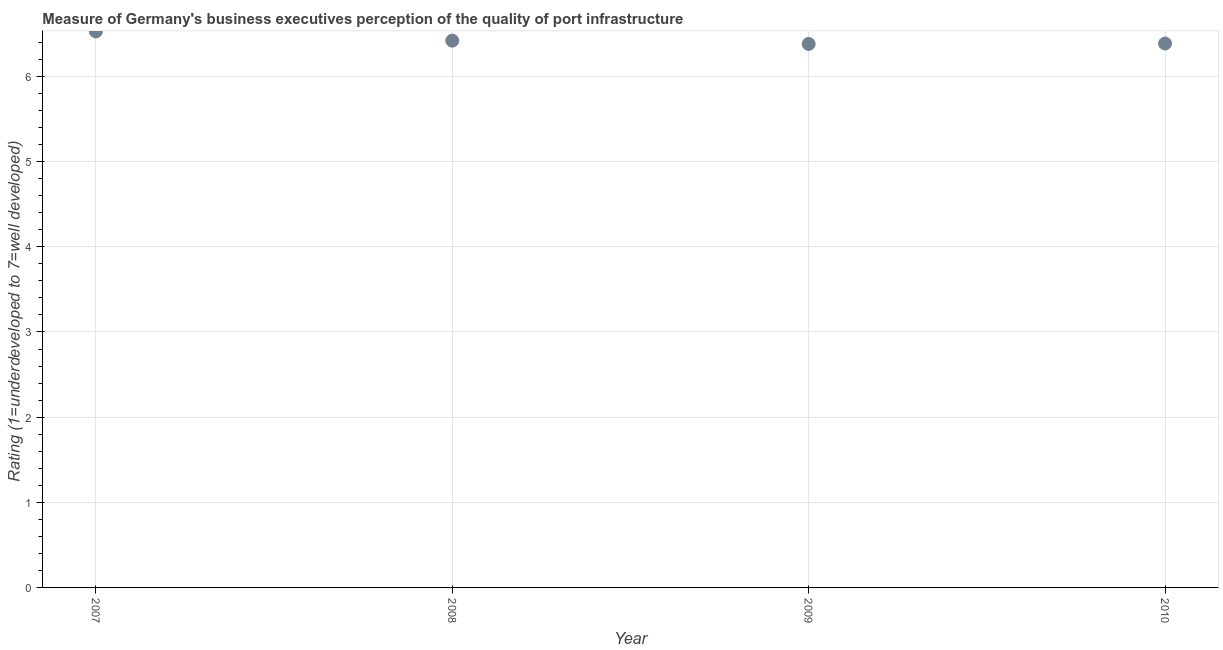What is the rating measuring quality of port infrastructure in 2008?
Ensure brevity in your answer.  6.42. Across all years, what is the maximum rating measuring quality of port infrastructure?
Keep it short and to the point. 6.53. Across all years, what is the minimum rating measuring quality of port infrastructure?
Make the answer very short. 6.38. What is the sum of the rating measuring quality of port infrastructure?
Your answer should be very brief. 25.72. What is the difference between the rating measuring quality of port infrastructure in 2007 and 2010?
Provide a short and direct response. 0.14. What is the average rating measuring quality of port infrastructure per year?
Give a very brief answer. 6.43. What is the median rating measuring quality of port infrastructure?
Offer a terse response. 6.4. In how many years, is the rating measuring quality of port infrastructure greater than 2.2 ?
Provide a short and direct response. 4. What is the ratio of the rating measuring quality of port infrastructure in 2007 to that in 2009?
Provide a short and direct response. 1.02. Is the rating measuring quality of port infrastructure in 2008 less than that in 2010?
Offer a terse response. No. Is the difference between the rating measuring quality of port infrastructure in 2008 and 2010 greater than the difference between any two years?
Give a very brief answer. No. What is the difference between the highest and the second highest rating measuring quality of port infrastructure?
Give a very brief answer. 0.11. Is the sum of the rating measuring quality of port infrastructure in 2009 and 2010 greater than the maximum rating measuring quality of port infrastructure across all years?
Offer a terse response. Yes. What is the difference between the highest and the lowest rating measuring quality of port infrastructure?
Keep it short and to the point. 0.15. Does the rating measuring quality of port infrastructure monotonically increase over the years?
Provide a short and direct response. No. How many years are there in the graph?
Give a very brief answer. 4. Are the values on the major ticks of Y-axis written in scientific E-notation?
Give a very brief answer. No. What is the title of the graph?
Make the answer very short. Measure of Germany's business executives perception of the quality of port infrastructure. What is the label or title of the Y-axis?
Provide a succinct answer. Rating (1=underdeveloped to 7=well developed) . What is the Rating (1=underdeveloped to 7=well developed)  in 2007?
Provide a short and direct response. 6.53. What is the Rating (1=underdeveloped to 7=well developed)  in 2008?
Offer a very short reply. 6.42. What is the Rating (1=underdeveloped to 7=well developed)  in 2009?
Provide a succinct answer. 6.38. What is the Rating (1=underdeveloped to 7=well developed)  in 2010?
Your response must be concise. 6.39. What is the difference between the Rating (1=underdeveloped to 7=well developed)  in 2007 and 2008?
Offer a very short reply. 0.11. What is the difference between the Rating (1=underdeveloped to 7=well developed)  in 2007 and 2009?
Provide a short and direct response. 0.15. What is the difference between the Rating (1=underdeveloped to 7=well developed)  in 2007 and 2010?
Offer a terse response. 0.14. What is the difference between the Rating (1=underdeveloped to 7=well developed)  in 2008 and 2009?
Your answer should be very brief. 0.04. What is the difference between the Rating (1=underdeveloped to 7=well developed)  in 2008 and 2010?
Provide a short and direct response. 0.03. What is the difference between the Rating (1=underdeveloped to 7=well developed)  in 2009 and 2010?
Offer a very short reply. -0. What is the ratio of the Rating (1=underdeveloped to 7=well developed)  in 2007 to that in 2008?
Provide a succinct answer. 1.02. What is the ratio of the Rating (1=underdeveloped to 7=well developed)  in 2007 to that in 2009?
Provide a short and direct response. 1.02. What is the ratio of the Rating (1=underdeveloped to 7=well developed)  in 2008 to that in 2009?
Offer a terse response. 1.01. What is the ratio of the Rating (1=underdeveloped to 7=well developed)  in 2009 to that in 2010?
Your response must be concise. 1. 